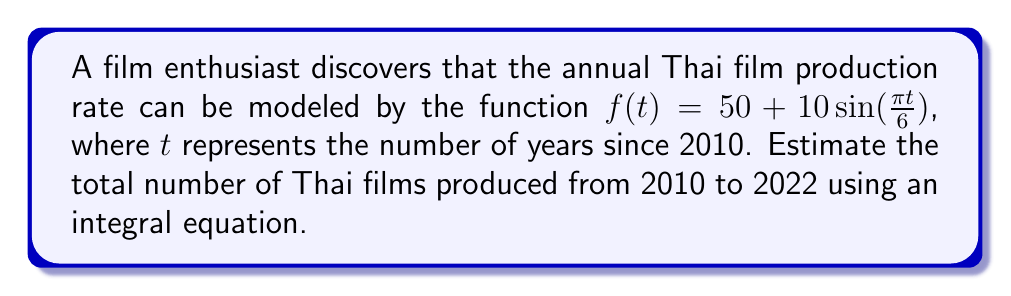Could you help me with this problem? To estimate the total number of Thai films produced from 2010 to 2022, we need to integrate the given function over the time interval [0, 12].

1. Set up the definite integral:
   $$\int_0^{12} (50 + 10\sin(\frac{\pi t}{6})) dt$$

2. Integrate the constant term:
   $$50t\Big|_0^{12} = 50 \cdot 12 = 600$$

3. Integrate the sine term:
   $$10 \int_0^{12} \sin(\frac{\pi t}{6}) dt$$
   
   Let $u = \frac{\pi t}{6}$, then $du = \frac{\pi}{6} dt$ and $dt = \frac{6}{\pi} du$
   
   $$10 \cdot \frac{6}{\pi} \int_0^{2\pi} \sin(u) du = -\frac{60}{\pi} \cos(u)\Big|_0^{2\pi} = -\frac{60}{\pi} (\cos(2\pi) - \cos(0)) = 0$$

4. Sum the results:
   Total = 600 + 0 = 600

Therefore, the estimated total number of Thai films produced from 2010 to 2022 is 600.
Answer: 600 films 